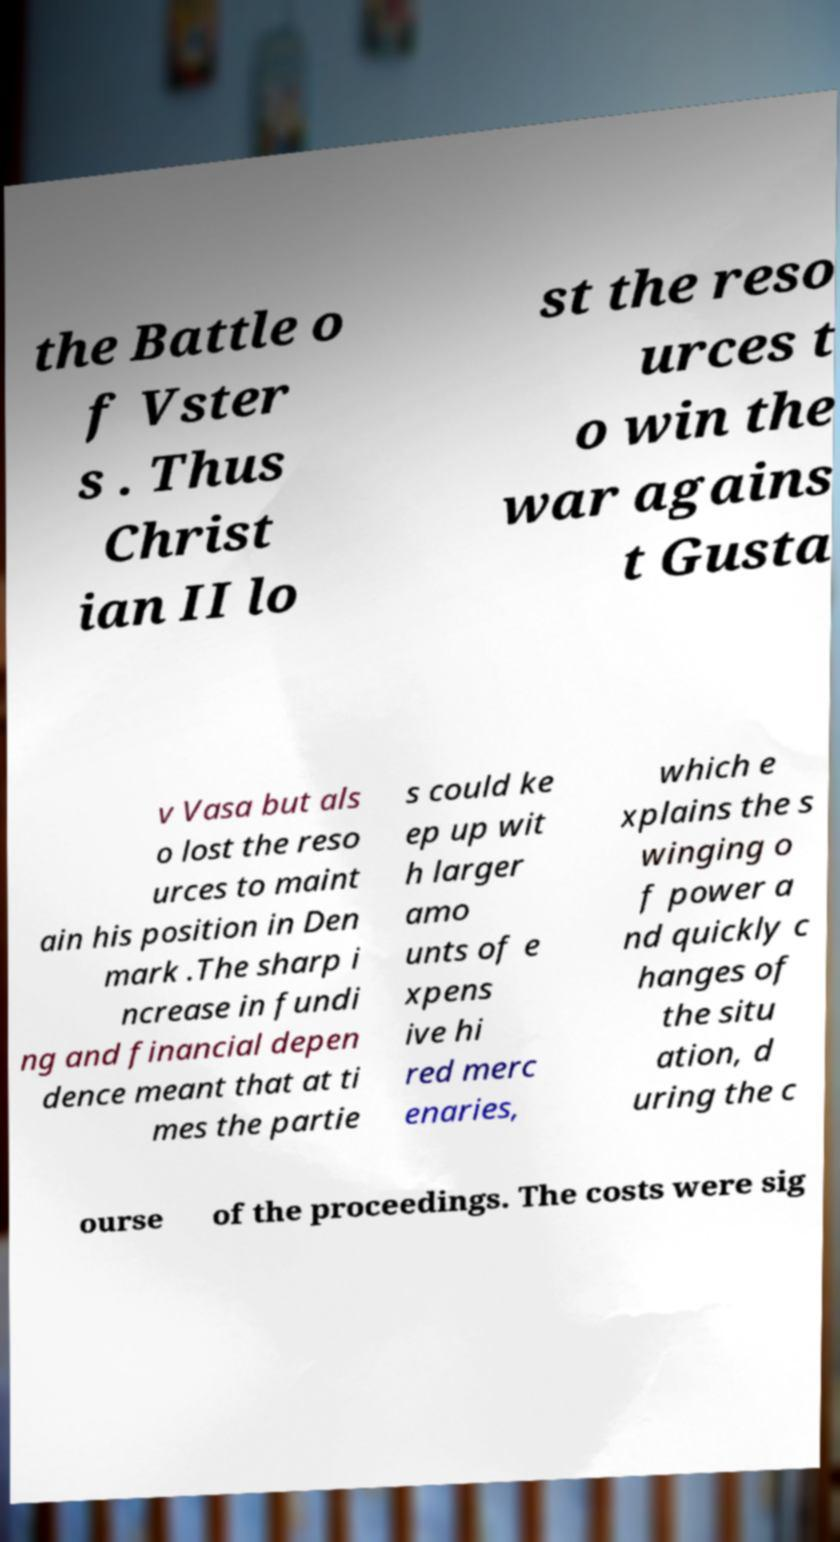Could you assist in decoding the text presented in this image and type it out clearly? the Battle o f Vster s . Thus Christ ian II lo st the reso urces t o win the war agains t Gusta v Vasa but als o lost the reso urces to maint ain his position in Den mark .The sharp i ncrease in fundi ng and financial depen dence meant that at ti mes the partie s could ke ep up wit h larger amo unts of e xpens ive hi red merc enaries, which e xplains the s winging o f power a nd quickly c hanges of the situ ation, d uring the c ourse of the proceedings. The costs were sig 